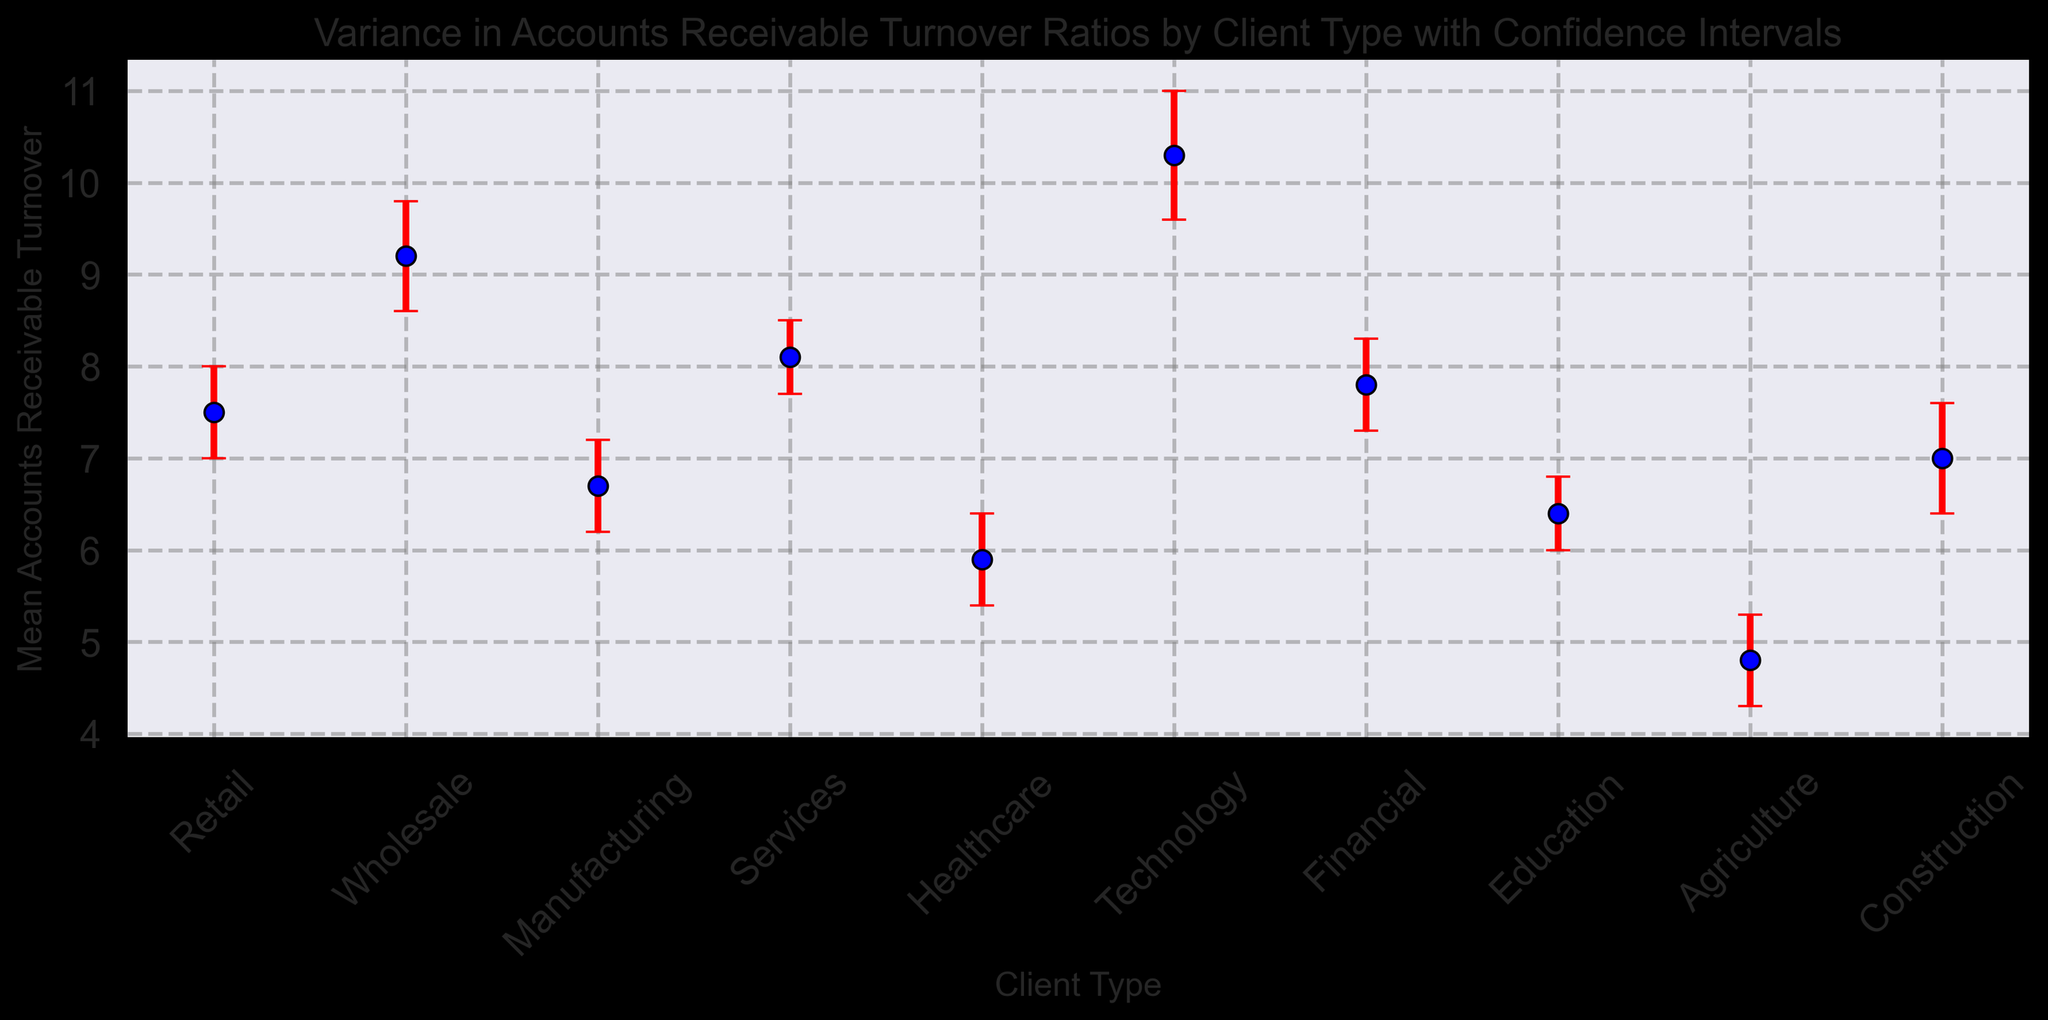What is the client type with the highest mean Accounts Receivable Turnover? From the plot, the Technology client type has the highest mark among all client types, indicating it has the highest mean Accounts Receivable Turnover.
Answer: Technology Which client type has the lowest mean Accounts Receivable Turnover? From the plot, the Agriculture client type has the lowest mark among all client types, indicating it has the lowest mean Accounts Receivable Turnover.
Answer: Agriculture What is the range of the Confidence Interval for Wholesale? The plot shows the lower CI for Wholesale at 8.6 and the upper CI at 9.8. The range of the Confidence Interval is the difference between the upper and lower CI, which is 9.8 - 8.6 = 1.2.
Answer: 1.2 How much greater is the mean Accounts Receivable Turnover for Technology compared to Healthcare? The mean for Technology is 10.3 and for Healthcare is 5.9. The difference is calculated as 10.3 - 5.9 = 4.4.
Answer: 4.4 Which client type has the largest variance in Accounts Receivable Turnover? From the plot, the error bars indicate the variance where technology has the largest extending error bars, hence the largest variance.
Answer: Technology Between Retail and Construction, which client type has a higher upper Confidence Interval? Retail has an upper CI of 8.0, and Construction has an upper CI of 7.6. Therefore, Retail has the higher upper CI.
Answer: Retail Considering all client types, which one has a mean Accounts Receivable Turnover closest to 8? From the plot, Retail has a mean Accounts Receivable Turnover of 7.5, which is closest to 8.
Answer: Retail What is the difference between the lower Confidence Interval of Manufacturing and Services? The lower CI for Manufacturing is 6.2 and for Services is 7.7. The difference is calculated as 7.7 - 6.2 = 1.5.
Answer: 1.5 